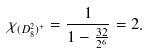Convert formula to latex. <formula><loc_0><loc_0><loc_500><loc_500>\chi _ { ( D _ { 8 } ^ { 2 } ) ^ { + } } = \frac { 1 } { 1 - \frac { 3 2 } { 2 ^ { 6 } } } = 2 .</formula> 